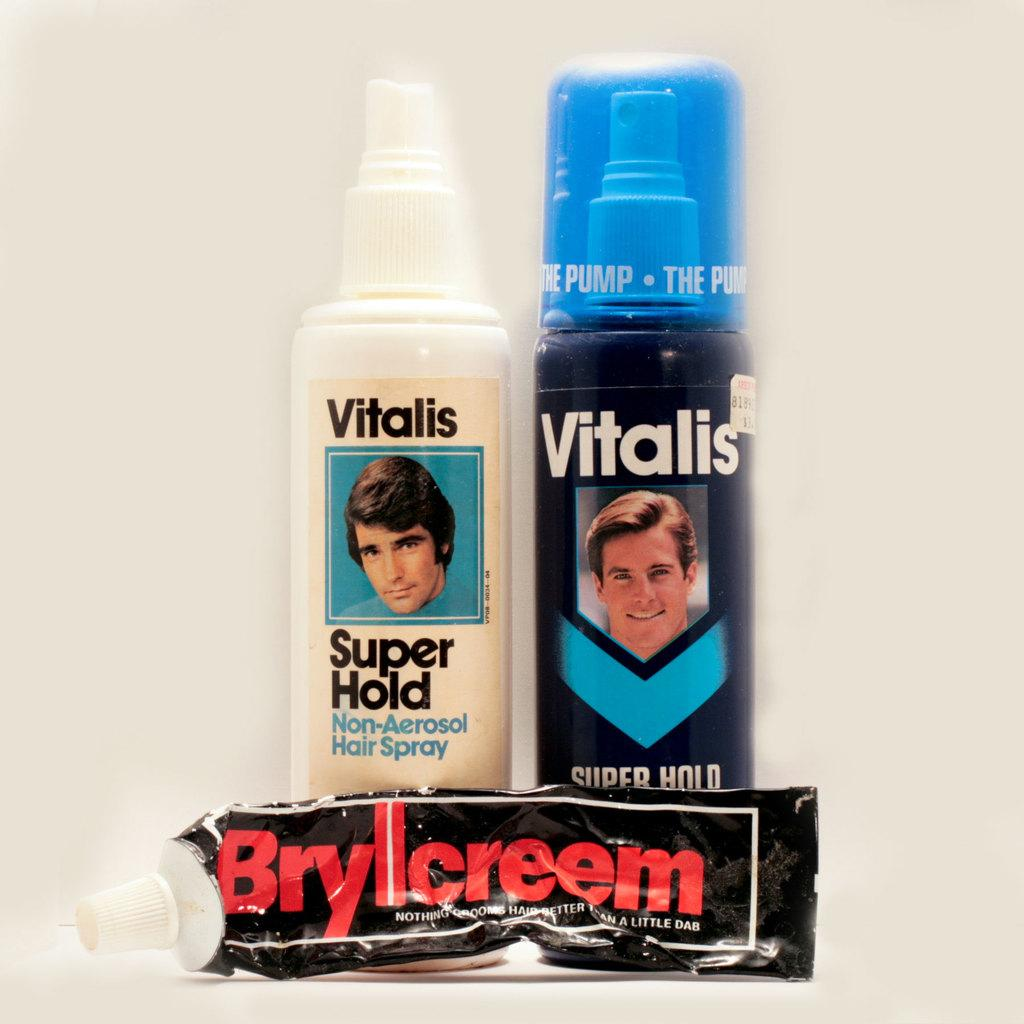<image>
Relay a brief, clear account of the picture shown. Two bottles and one that has Vitalis written on it 